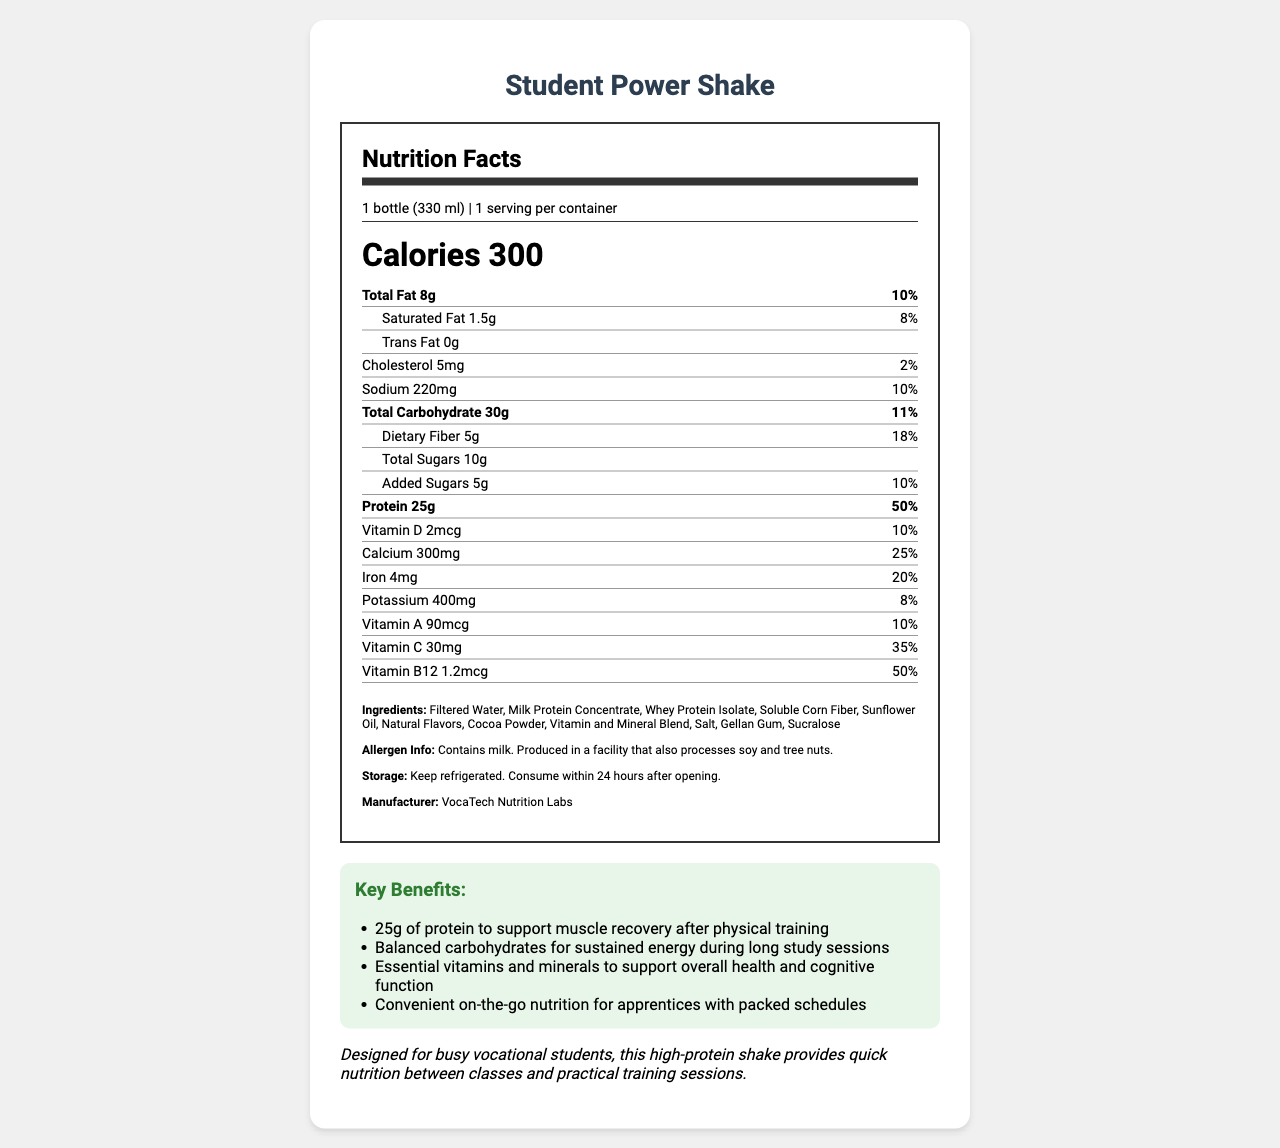what is the serving size? The serving size is specified at the beginning of the Nutrition Facts, which indicates 1 bottle of 330 ml.
Answer: 1 bottle (330 ml) how many calories are in one serving of the Student Power Shake? The number of calories per serving is clearly listed as 300.
Answer: 300 what is the amount of total fat in the shake? The total fat content is mentioned as 8g in the nutrition section.
Answer: 8g what benefits does the shake offer? The key benefits are listed and include 25g of protein, balanced carbohydrates, essential vitamins and minerals, and convenient on-the-go nutrition.
Answer: 25g of protein, balanced carbohydrates, essential vitamins and minerals, convenient on-the-go nutrition how much sodium is in the shake? The sodium content is indicated as 220mg in the nutrition label.
Answer: 220mg how many grams of dietary fiber are in one serving? A. 3g B. 5g C. 8g D. 10g The dietary fiber content is specified as 5g.
Answer: B what type of protein is used in the Student Power Shake? A. Soy Protein Isolate B. Wheat Protein Isolate C. Whey Protein Isolate D. Pea Protein Isolate Among the ingredients, Whey Protein Isolate is listed.
Answer: C does the shake contain any vitamin B12? The nutrition facts indicate that the shake contains 1.2mcg of vitamin B12.
Answer: Yes describe the main idea of the document. The main idea captures the emphasis on the nutritional content and benefits provided by the shake for vocational students.
Answer: The document is a Nutrition Facts label for the Student Power Shake, a high-protein meal replacement drink designed for busy vocational students. It provides comprehensive details about serving size, calorie content, macronutrients, vitamins, minerals, ingredients, allergens, and storage instructions, emphasizing its benefits for muscle recovery, sustained energy, overall health, and convenience. is the Student Power Shake free from trans fat? The document specifies that the trans fat content is 0g.
Answer: Yes does the shake contain any allergens? The allergen information section details that it contains milk and could be contaminated with soy and tree nuts due to the production facility.
Answer: Yes, it contains milk. It is also produced in a facility that processes soy and tree nuts. what is the manufacturer of the Student Power Shake? The manufacturer is listed towards the end of the document under the ingredient and allergen information sections.
Answer: VocaTech Nutrition Labs how much calcium is in one serving of the shake? The calcium content is listed as 300mg.
Answer: 300mg what is the protein content per serving of the shake? The protein content is listed prominently on the label as 25g.
Answer: 25g how long can the shake be consumed after opening? The storage instructions specify that the shake should be consumed within 24 hours after opening.
Answer: Within 24 hours after opening what is the recommended storage condition for the Student Power Shake? The instructions specify that the shake should be kept refrigerated.
Answer: Refrigerated how much vitamin D is present per serving? The vitamin D content in the shake is listed as 2mcg.
Answer: 2mcg is the Student Power Shake suitable for someone with a tree nut allergy? The shake contains milk and is produced in a facility that processes tree nuts, making it unclear if it is suitable for someone with a tree nut allergy.
Answer: Cannot be determined what type of fiber is included in the ingredient list? The ingredients section lists Soluble Corn Fiber as the type of fiber included in the shake.
Answer: Soluble Corn Fiber 